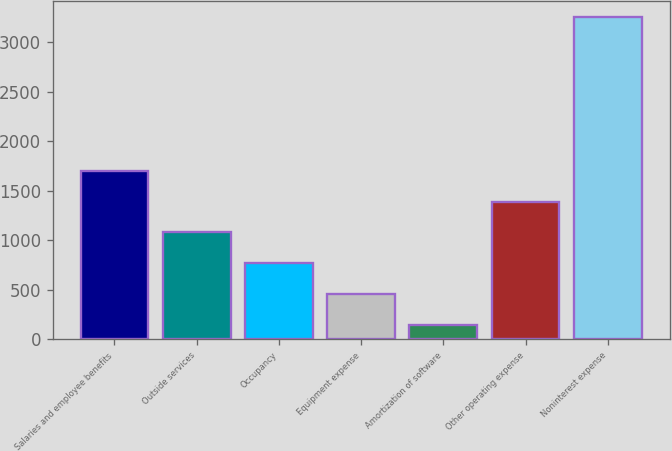Convert chart to OTSL. <chart><loc_0><loc_0><loc_500><loc_500><bar_chart><fcel>Salaries and employee benefits<fcel>Outside services<fcel>Occupancy<fcel>Equipment expense<fcel>Amortization of software<fcel>Other operating expense<fcel>Noninterest expense<nl><fcel>1702.5<fcel>1079.9<fcel>768.6<fcel>457.3<fcel>146<fcel>1391.2<fcel>3259<nl></chart> 